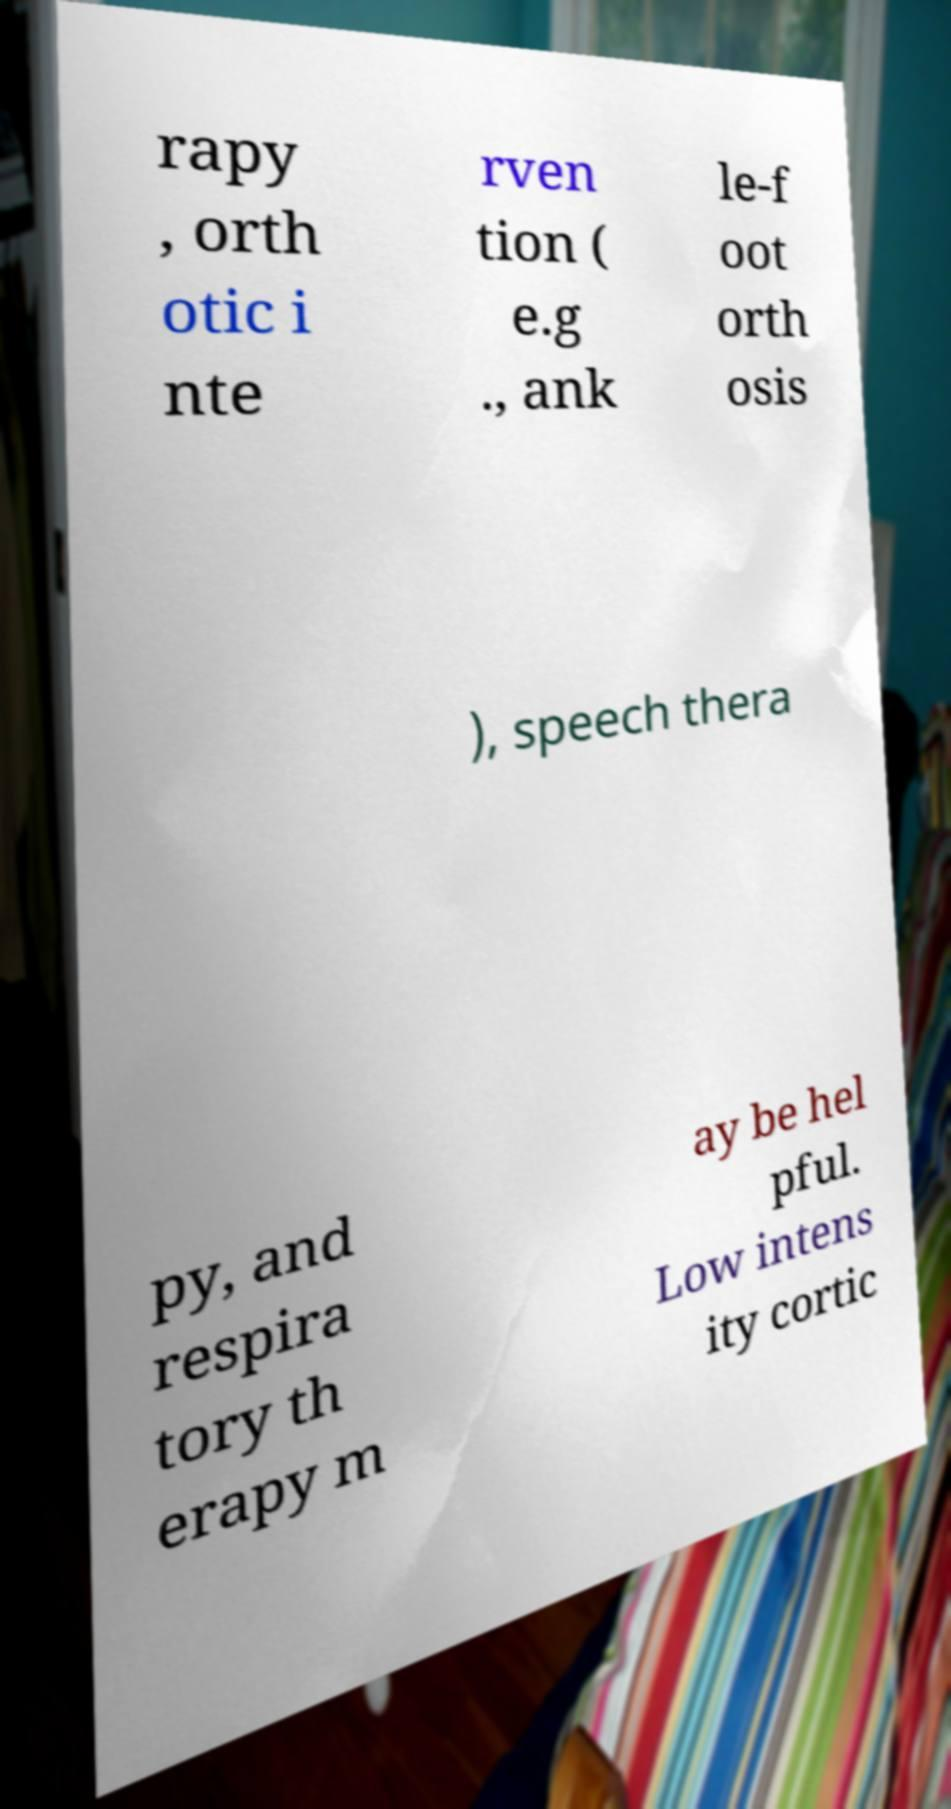Please identify and transcribe the text found in this image. rapy , orth otic i nte rven tion ( e.g ., ank le-f oot orth osis ), speech thera py, and respira tory th erapy m ay be hel pful. Low intens ity cortic 